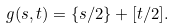Convert formula to latex. <formula><loc_0><loc_0><loc_500><loc_500>g ( s , t ) = \{ s / 2 \} + [ t / 2 ] .</formula> 